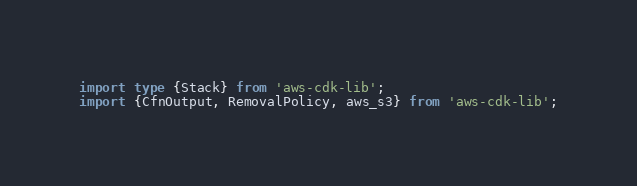<code> <loc_0><loc_0><loc_500><loc_500><_TypeScript_>import type {Stack} from 'aws-cdk-lib';
import {CfnOutput, RemovalPolicy, aws_s3} from 'aws-cdk-lib';
</code> 